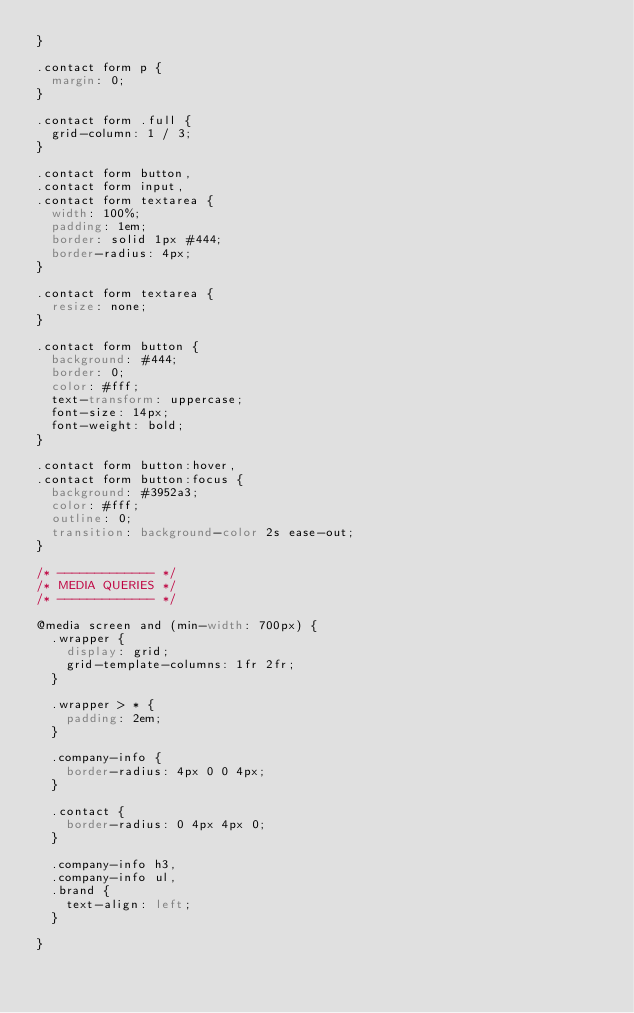<code> <loc_0><loc_0><loc_500><loc_500><_CSS_>}

.contact form p {
  margin: 0;
}

.contact form .full {
  grid-column: 1 / 3;
}

.contact form button,
.contact form input,
.contact form textarea {
  width: 100%;
  padding: 1em;
  border: solid 1px #444;
  border-radius: 4px;
}

.contact form textarea {
  resize: none;
}

.contact form button {
  background: #444;
  border: 0;
  color: #fff;
  text-transform: uppercase;
  font-size: 14px;
  font-weight: bold;
}

.contact form button:hover,
.contact form button:focus {
  background: #3952a3;
  color: #fff;
  outline: 0;
  transition: background-color 2s ease-out;
}

/* ------------- */
/* MEDIA QUERIES */
/* ------------- */

@media screen and (min-width: 700px) {
  .wrapper {
    display: grid;
    grid-template-columns: 1fr 2fr;
  }

  .wrapper > * {
    padding: 2em;
  }

  .company-info {
    border-radius: 4px 0 0 4px;
  }

  .contact {
    border-radius: 0 4px 4px 0;
  }

  .company-info h3,
  .company-info ul,
  .brand {
    text-align: left;
  }

}</code> 